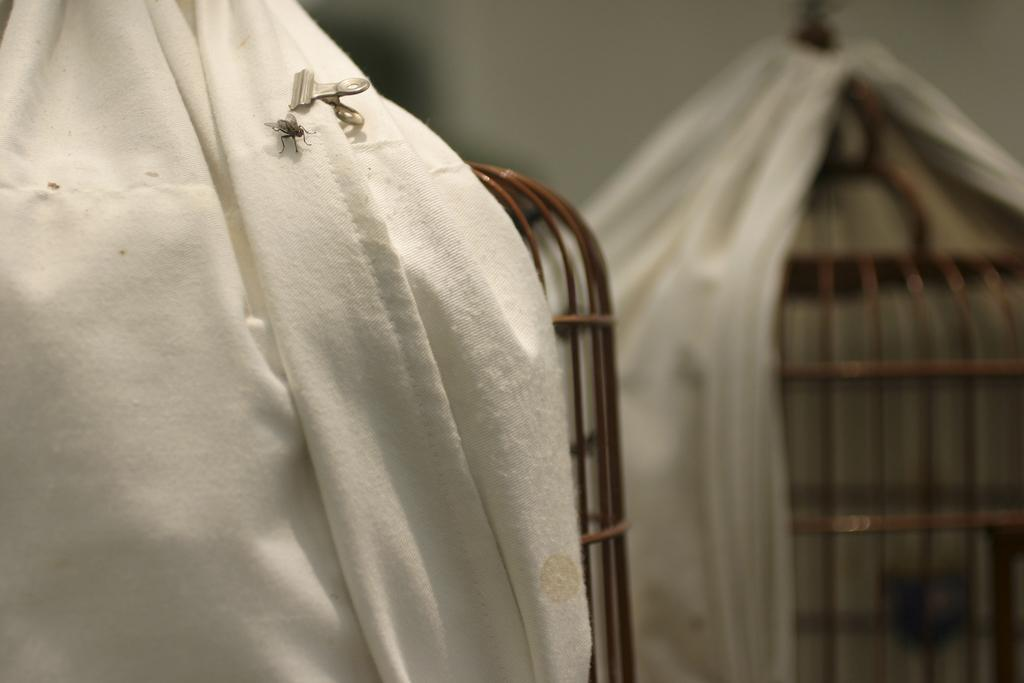What is the main object in the image? There is a white cloth in the image. What is present on the white cloth? There is a fly on the white cloth. Can you describe any other objects visible in the image? There are other objects visible in the background of the image. How many men are visible in the image? There is no mention of men in the image, so it cannot be determined how many men are visible. What type of snail can be seen crawling on the white cloth? There is no snail present on the white cloth in the image. 